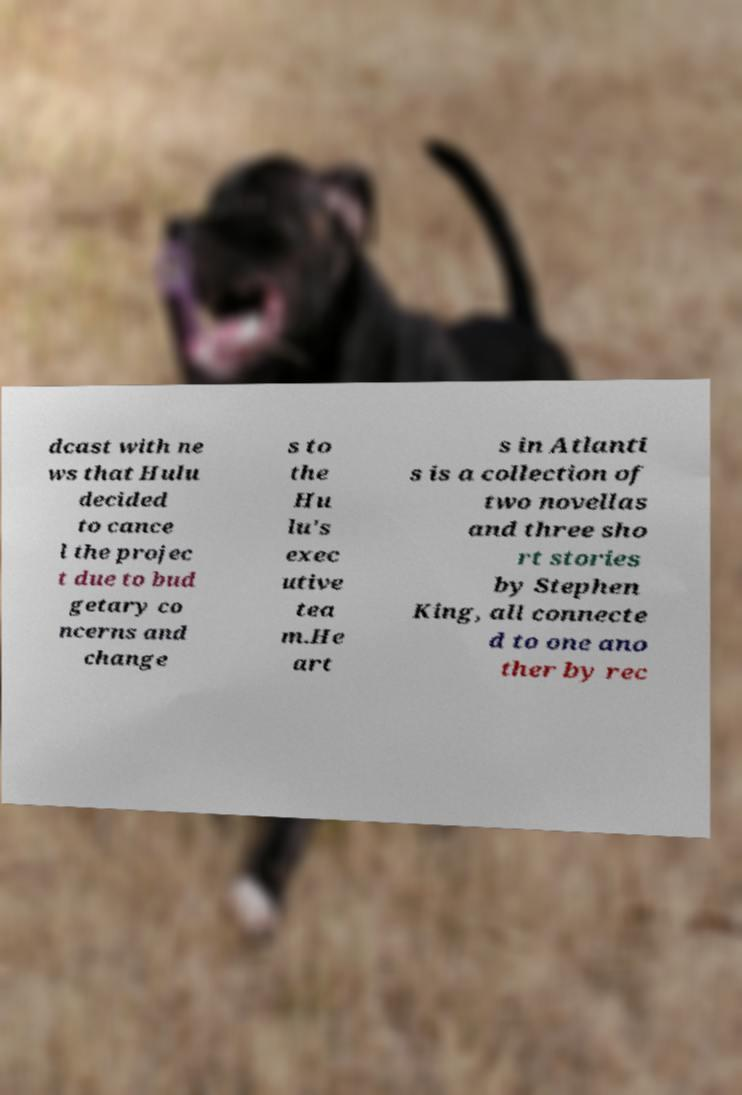I need the written content from this picture converted into text. Can you do that? dcast with ne ws that Hulu decided to cance l the projec t due to bud getary co ncerns and change s to the Hu lu's exec utive tea m.He art s in Atlanti s is a collection of two novellas and three sho rt stories by Stephen King, all connecte d to one ano ther by rec 